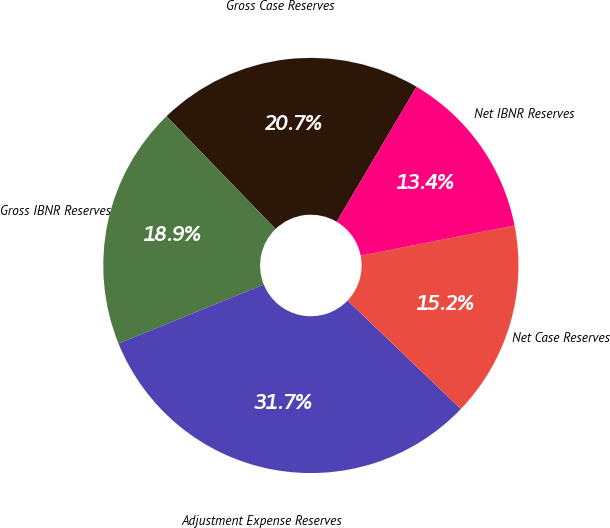Convert chart. <chart><loc_0><loc_0><loc_500><loc_500><pie_chart><fcel>Gross Case Reserves<fcel>Gross IBNR Reserves<fcel>Adjustment Expense Reserves<fcel>Net Case Reserves<fcel>Net IBNR Reserves<nl><fcel>20.73%<fcel>18.9%<fcel>31.72%<fcel>15.24%<fcel>13.41%<nl></chart> 